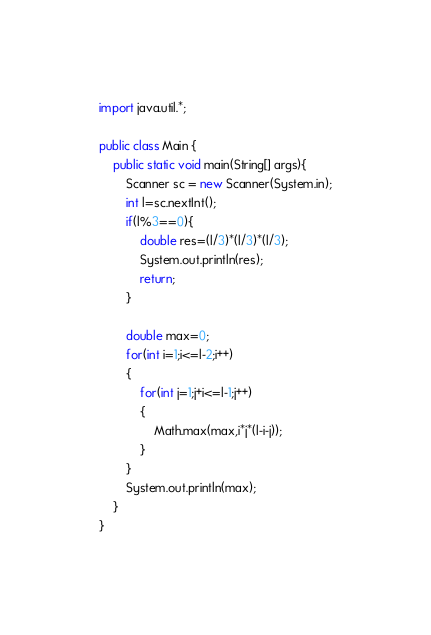Convert code to text. <code><loc_0><loc_0><loc_500><loc_500><_Java_>import java.util.*;

public class Main {
    public static void main(String[] args){
        Scanner sc = new Scanner(System.in);
        int l=sc.nextInt();
        if(l%3==0){
            double res=(l/3)*(l/3)*(l/3);
            System.out.println(res);
            return;
        }

        double max=0;
        for(int i=1;i<=l-2;i++)
        {
            for(int j=1;j+i<=l-1;j++)
            {
                Math.max(max,i*j*(l-i-j));
            }
        }
        System.out.println(max);
    }
}</code> 